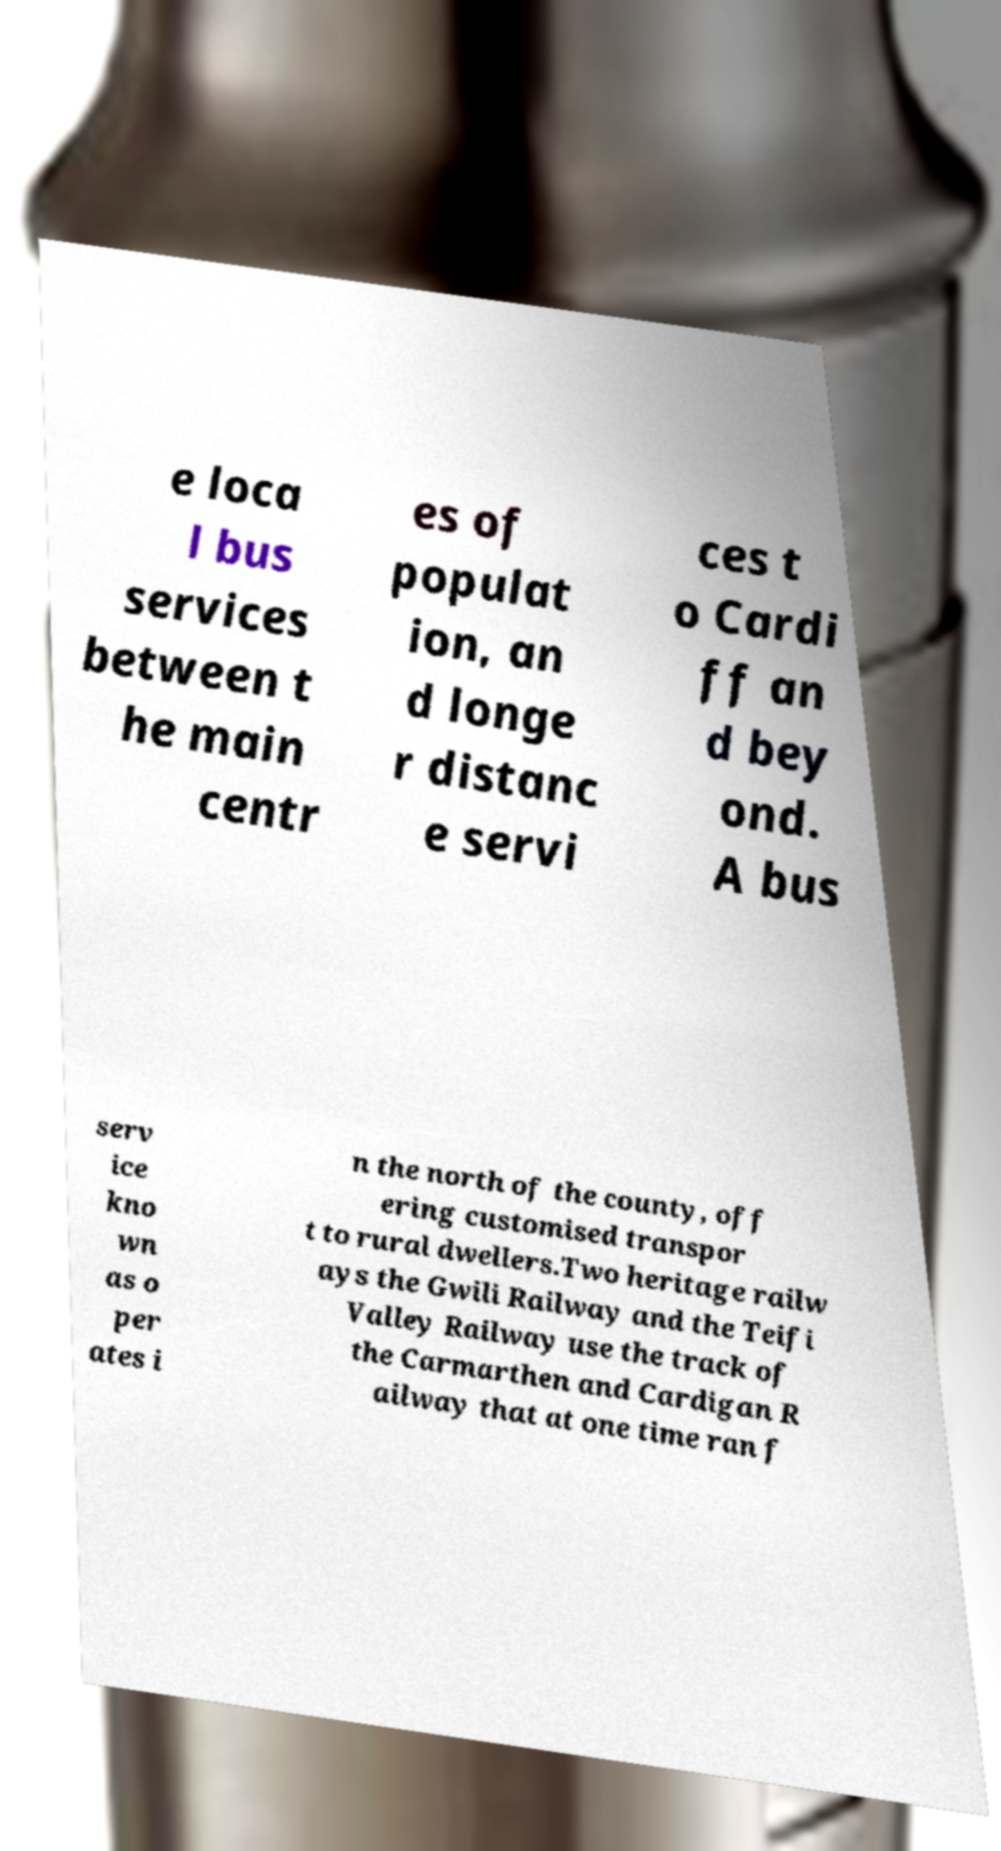Can you accurately transcribe the text from the provided image for me? e loca l bus services between t he main centr es of populat ion, an d longe r distanc e servi ces t o Cardi ff an d bey ond. A bus serv ice kno wn as o per ates i n the north of the county, off ering customised transpor t to rural dwellers.Two heritage railw ays the Gwili Railway and the Teifi Valley Railway use the track of the Carmarthen and Cardigan R ailway that at one time ran f 